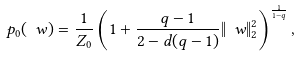Convert formula to latex. <formula><loc_0><loc_0><loc_500><loc_500>p _ { 0 } ( \ w ) = \frac { 1 } { Z _ { 0 } } \left ( 1 + \frac { q - 1 } { 2 - d ( q - 1 ) } \| \ w \| _ { 2 } ^ { 2 } \right ) ^ { \frac { 1 } { 1 - q } } ,</formula> 